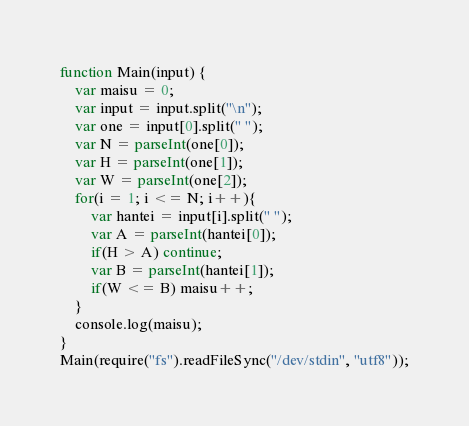<code> <loc_0><loc_0><loc_500><loc_500><_JavaScript_>function Main(input) {
    var maisu = 0;
    var input = input.split("\n");
    var one = input[0].split(" ");
    var N = parseInt(one[0]);
    var H = parseInt(one[1]);
    var W = parseInt(one[2]);
    for(i = 1; i <= N; i++){
        var hantei = input[i].split(" ");
        var A = parseInt(hantei[0]);
        if(H > A) continue;
        var B = parseInt(hantei[1]);
        if(W <= B) maisu++;
    }
	console.log(maisu);
}
Main(require("fs").readFileSync("/dev/stdin", "utf8"));</code> 